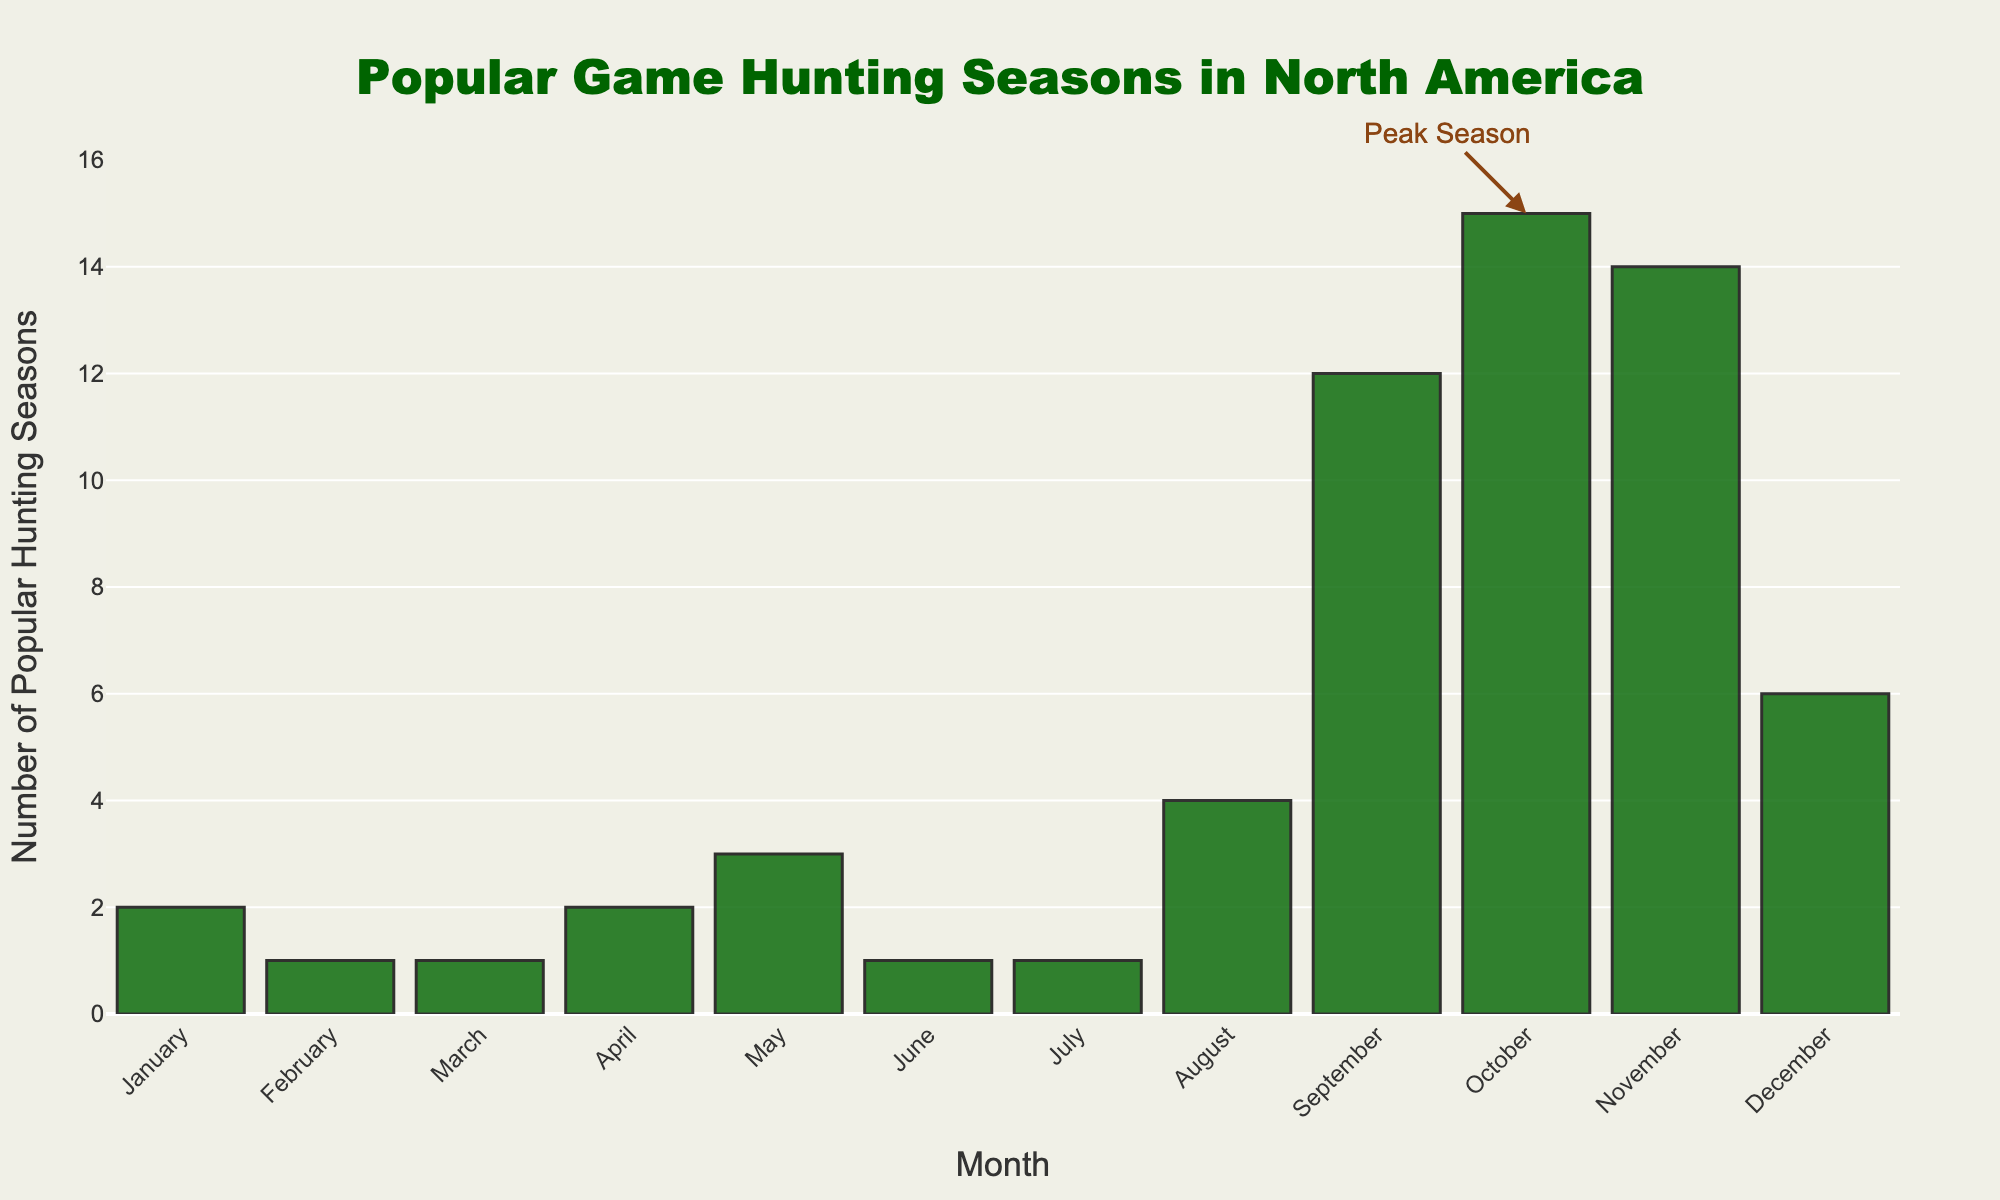Which month has the highest number of popular hunting seasons? The bar representing October is the tallest, indicating it has the highest number of popular hunting seasons.
Answer: October How many more popular hunting seasons are there in November compared to January? November has 14 popular hunting seasons while January has 2. The difference is 14 - 2 = 12.
Answer: 12 Which months have fewer than two popular hunting seasons? The bars for February, March, June, and July all have heights indicating fewer than two popular hunting seasons.
Answer: February, March, June, July What is the total number of popular hunting seasons in the summer months (June, July, and August)? The numbers for June, July, and August are 1, 1, and 4 respectively. Summing these gives 1 + 1 + 4 = 6.
Answer: 6 What is the peak hunting season, and how do you know? The bar for October has an annotation "Peak Season" and it is the tallest bar, indicating it has the most popular hunting seasons.
Answer: October Which season is highlighted by an annotation, and what does it signify? The bar for October has an annotation that signifies it as the "Peak Season" for game hunting.
Answer: October How many months have 3 or more popular hunting seasons? The months with 3 or more popular hunting seasons are May, August, September, October, November, and December. Counting these gives 6 months.
Answer: 6 Is the number of popular hunting seasons in December greater than in April? December has 6 popular hunting seasons while April has 2. Since 6 > 2, the number in December is greater than in April.
Answer: Yes What is the total number of popular hunting seasons shown in the figure? Adding up all the numbers: 2 (Jan) + 1 (Feb) + 1 (Mar) + 2 (Apr) + 3 (May) + 1 (Jun) + 1 (Jul) + 4 (Aug) + 12 (Sep) + 15 (Oct) + 14 (Nov) + 6 (Dec) = 62.
Answer: 62 Which months have the same number of popular hunting seasons and what is that number? January and April both have 2 popular hunting seasons, and February, March, June, and July all have 1.
Answer: January-April (2), February-March-June-July (1) 